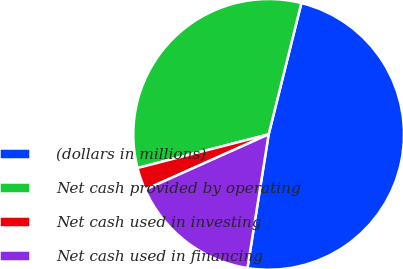Convert chart. <chart><loc_0><loc_0><loc_500><loc_500><pie_chart><fcel>(dollars in millions)<fcel>Net cash provided by operating<fcel>Net cash used in investing<fcel>Net cash used in financing<nl><fcel>48.61%<fcel>32.88%<fcel>2.7%<fcel>15.8%<nl></chart> 